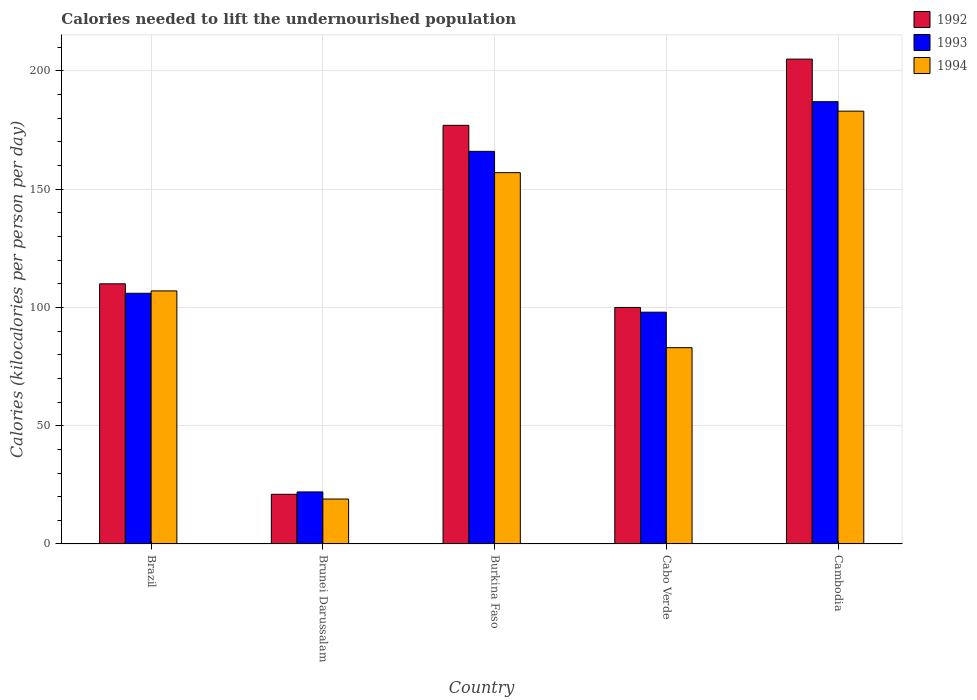How many groups of bars are there?
Ensure brevity in your answer.  5. How many bars are there on the 5th tick from the left?
Your response must be concise. 3. What is the label of the 2nd group of bars from the left?
Offer a very short reply. Brunei Darussalam. In how many cases, is the number of bars for a given country not equal to the number of legend labels?
Your answer should be very brief. 0. Across all countries, what is the maximum total calories needed to lift the undernourished population in 1993?
Offer a terse response. 187. In which country was the total calories needed to lift the undernourished population in 1992 maximum?
Offer a terse response. Cambodia. In which country was the total calories needed to lift the undernourished population in 1992 minimum?
Give a very brief answer. Brunei Darussalam. What is the total total calories needed to lift the undernourished population in 1992 in the graph?
Make the answer very short. 613. What is the difference between the total calories needed to lift the undernourished population in 1994 in Cabo Verde and that in Cambodia?
Provide a succinct answer. -100. What is the difference between the total calories needed to lift the undernourished population in 1993 in Brunei Darussalam and the total calories needed to lift the undernourished population in 1994 in Brazil?
Offer a very short reply. -85. What is the average total calories needed to lift the undernourished population in 1992 per country?
Ensure brevity in your answer.  122.6. What is the difference between the total calories needed to lift the undernourished population of/in 1993 and total calories needed to lift the undernourished population of/in 1992 in Burkina Faso?
Provide a succinct answer. -11. In how many countries, is the total calories needed to lift the undernourished population in 1992 greater than 200 kilocalories?
Offer a very short reply. 1. What is the ratio of the total calories needed to lift the undernourished population in 1994 in Burkina Faso to that in Cabo Verde?
Your answer should be very brief. 1.89. Is the total calories needed to lift the undernourished population in 1993 in Brazil less than that in Cabo Verde?
Provide a succinct answer. No. Is the difference between the total calories needed to lift the undernourished population in 1993 in Burkina Faso and Cambodia greater than the difference between the total calories needed to lift the undernourished population in 1992 in Burkina Faso and Cambodia?
Your response must be concise. Yes. What is the difference between the highest and the second highest total calories needed to lift the undernourished population in 1993?
Your response must be concise. -81. What is the difference between the highest and the lowest total calories needed to lift the undernourished population in 1992?
Provide a short and direct response. 184. In how many countries, is the total calories needed to lift the undernourished population in 1994 greater than the average total calories needed to lift the undernourished population in 1994 taken over all countries?
Your answer should be compact. 2. Is the sum of the total calories needed to lift the undernourished population in 1993 in Brunei Darussalam and Cabo Verde greater than the maximum total calories needed to lift the undernourished population in 1992 across all countries?
Keep it short and to the point. No. What does the 1st bar from the left in Brunei Darussalam represents?
Make the answer very short. 1992. What does the 3rd bar from the right in Brazil represents?
Provide a succinct answer. 1992. How many countries are there in the graph?
Your answer should be compact. 5. Does the graph contain any zero values?
Give a very brief answer. No. Where does the legend appear in the graph?
Provide a succinct answer. Top right. How many legend labels are there?
Your response must be concise. 3. What is the title of the graph?
Provide a succinct answer. Calories needed to lift the undernourished population. Does "2012" appear as one of the legend labels in the graph?
Give a very brief answer. No. What is the label or title of the Y-axis?
Ensure brevity in your answer.  Calories (kilocalories per person per day). What is the Calories (kilocalories per person per day) of 1992 in Brazil?
Ensure brevity in your answer.  110. What is the Calories (kilocalories per person per day) in 1993 in Brazil?
Keep it short and to the point. 106. What is the Calories (kilocalories per person per day) in 1994 in Brazil?
Your answer should be compact. 107. What is the Calories (kilocalories per person per day) of 1992 in Burkina Faso?
Keep it short and to the point. 177. What is the Calories (kilocalories per person per day) in 1993 in Burkina Faso?
Your response must be concise. 166. What is the Calories (kilocalories per person per day) in 1994 in Burkina Faso?
Ensure brevity in your answer.  157. What is the Calories (kilocalories per person per day) in 1992 in Cabo Verde?
Your answer should be very brief. 100. What is the Calories (kilocalories per person per day) in 1994 in Cabo Verde?
Provide a short and direct response. 83. What is the Calories (kilocalories per person per day) in 1992 in Cambodia?
Offer a terse response. 205. What is the Calories (kilocalories per person per day) in 1993 in Cambodia?
Offer a very short reply. 187. What is the Calories (kilocalories per person per day) in 1994 in Cambodia?
Ensure brevity in your answer.  183. Across all countries, what is the maximum Calories (kilocalories per person per day) of 1992?
Provide a succinct answer. 205. Across all countries, what is the maximum Calories (kilocalories per person per day) in 1993?
Ensure brevity in your answer.  187. Across all countries, what is the maximum Calories (kilocalories per person per day) in 1994?
Provide a short and direct response. 183. Across all countries, what is the minimum Calories (kilocalories per person per day) in 1992?
Ensure brevity in your answer.  21. Across all countries, what is the minimum Calories (kilocalories per person per day) of 1994?
Offer a terse response. 19. What is the total Calories (kilocalories per person per day) of 1992 in the graph?
Provide a short and direct response. 613. What is the total Calories (kilocalories per person per day) of 1993 in the graph?
Make the answer very short. 579. What is the total Calories (kilocalories per person per day) in 1994 in the graph?
Provide a short and direct response. 549. What is the difference between the Calories (kilocalories per person per day) in 1992 in Brazil and that in Brunei Darussalam?
Provide a short and direct response. 89. What is the difference between the Calories (kilocalories per person per day) of 1992 in Brazil and that in Burkina Faso?
Make the answer very short. -67. What is the difference between the Calories (kilocalories per person per day) in 1993 in Brazil and that in Burkina Faso?
Provide a short and direct response. -60. What is the difference between the Calories (kilocalories per person per day) of 1994 in Brazil and that in Burkina Faso?
Offer a very short reply. -50. What is the difference between the Calories (kilocalories per person per day) of 1992 in Brazil and that in Cabo Verde?
Ensure brevity in your answer.  10. What is the difference between the Calories (kilocalories per person per day) of 1992 in Brazil and that in Cambodia?
Keep it short and to the point. -95. What is the difference between the Calories (kilocalories per person per day) of 1993 in Brazil and that in Cambodia?
Offer a very short reply. -81. What is the difference between the Calories (kilocalories per person per day) in 1994 in Brazil and that in Cambodia?
Give a very brief answer. -76. What is the difference between the Calories (kilocalories per person per day) in 1992 in Brunei Darussalam and that in Burkina Faso?
Provide a short and direct response. -156. What is the difference between the Calories (kilocalories per person per day) of 1993 in Brunei Darussalam and that in Burkina Faso?
Provide a short and direct response. -144. What is the difference between the Calories (kilocalories per person per day) in 1994 in Brunei Darussalam and that in Burkina Faso?
Your answer should be very brief. -138. What is the difference between the Calories (kilocalories per person per day) of 1992 in Brunei Darussalam and that in Cabo Verde?
Ensure brevity in your answer.  -79. What is the difference between the Calories (kilocalories per person per day) in 1993 in Brunei Darussalam and that in Cabo Verde?
Your answer should be compact. -76. What is the difference between the Calories (kilocalories per person per day) of 1994 in Brunei Darussalam and that in Cabo Verde?
Keep it short and to the point. -64. What is the difference between the Calories (kilocalories per person per day) of 1992 in Brunei Darussalam and that in Cambodia?
Offer a very short reply. -184. What is the difference between the Calories (kilocalories per person per day) in 1993 in Brunei Darussalam and that in Cambodia?
Offer a very short reply. -165. What is the difference between the Calories (kilocalories per person per day) of 1994 in Brunei Darussalam and that in Cambodia?
Ensure brevity in your answer.  -164. What is the difference between the Calories (kilocalories per person per day) of 1993 in Burkina Faso and that in Cabo Verde?
Provide a short and direct response. 68. What is the difference between the Calories (kilocalories per person per day) of 1992 in Burkina Faso and that in Cambodia?
Provide a short and direct response. -28. What is the difference between the Calories (kilocalories per person per day) of 1994 in Burkina Faso and that in Cambodia?
Keep it short and to the point. -26. What is the difference between the Calories (kilocalories per person per day) in 1992 in Cabo Verde and that in Cambodia?
Your answer should be very brief. -105. What is the difference between the Calories (kilocalories per person per day) in 1993 in Cabo Verde and that in Cambodia?
Your answer should be compact. -89. What is the difference between the Calories (kilocalories per person per day) of 1994 in Cabo Verde and that in Cambodia?
Keep it short and to the point. -100. What is the difference between the Calories (kilocalories per person per day) of 1992 in Brazil and the Calories (kilocalories per person per day) of 1993 in Brunei Darussalam?
Keep it short and to the point. 88. What is the difference between the Calories (kilocalories per person per day) of 1992 in Brazil and the Calories (kilocalories per person per day) of 1994 in Brunei Darussalam?
Offer a very short reply. 91. What is the difference between the Calories (kilocalories per person per day) in 1993 in Brazil and the Calories (kilocalories per person per day) in 1994 in Brunei Darussalam?
Make the answer very short. 87. What is the difference between the Calories (kilocalories per person per day) in 1992 in Brazil and the Calories (kilocalories per person per day) in 1993 in Burkina Faso?
Your answer should be very brief. -56. What is the difference between the Calories (kilocalories per person per day) of 1992 in Brazil and the Calories (kilocalories per person per day) of 1994 in Burkina Faso?
Offer a very short reply. -47. What is the difference between the Calories (kilocalories per person per day) of 1993 in Brazil and the Calories (kilocalories per person per day) of 1994 in Burkina Faso?
Your answer should be very brief. -51. What is the difference between the Calories (kilocalories per person per day) of 1992 in Brazil and the Calories (kilocalories per person per day) of 1994 in Cabo Verde?
Your answer should be very brief. 27. What is the difference between the Calories (kilocalories per person per day) of 1993 in Brazil and the Calories (kilocalories per person per day) of 1994 in Cabo Verde?
Ensure brevity in your answer.  23. What is the difference between the Calories (kilocalories per person per day) in 1992 in Brazil and the Calories (kilocalories per person per day) in 1993 in Cambodia?
Give a very brief answer. -77. What is the difference between the Calories (kilocalories per person per day) of 1992 in Brazil and the Calories (kilocalories per person per day) of 1994 in Cambodia?
Your answer should be compact. -73. What is the difference between the Calories (kilocalories per person per day) in 1993 in Brazil and the Calories (kilocalories per person per day) in 1994 in Cambodia?
Keep it short and to the point. -77. What is the difference between the Calories (kilocalories per person per day) in 1992 in Brunei Darussalam and the Calories (kilocalories per person per day) in 1993 in Burkina Faso?
Give a very brief answer. -145. What is the difference between the Calories (kilocalories per person per day) of 1992 in Brunei Darussalam and the Calories (kilocalories per person per day) of 1994 in Burkina Faso?
Keep it short and to the point. -136. What is the difference between the Calories (kilocalories per person per day) of 1993 in Brunei Darussalam and the Calories (kilocalories per person per day) of 1994 in Burkina Faso?
Give a very brief answer. -135. What is the difference between the Calories (kilocalories per person per day) in 1992 in Brunei Darussalam and the Calories (kilocalories per person per day) in 1993 in Cabo Verde?
Your answer should be compact. -77. What is the difference between the Calories (kilocalories per person per day) of 1992 in Brunei Darussalam and the Calories (kilocalories per person per day) of 1994 in Cabo Verde?
Offer a terse response. -62. What is the difference between the Calories (kilocalories per person per day) in 1993 in Brunei Darussalam and the Calories (kilocalories per person per day) in 1994 in Cabo Verde?
Offer a terse response. -61. What is the difference between the Calories (kilocalories per person per day) in 1992 in Brunei Darussalam and the Calories (kilocalories per person per day) in 1993 in Cambodia?
Offer a very short reply. -166. What is the difference between the Calories (kilocalories per person per day) of 1992 in Brunei Darussalam and the Calories (kilocalories per person per day) of 1994 in Cambodia?
Provide a succinct answer. -162. What is the difference between the Calories (kilocalories per person per day) in 1993 in Brunei Darussalam and the Calories (kilocalories per person per day) in 1994 in Cambodia?
Your answer should be very brief. -161. What is the difference between the Calories (kilocalories per person per day) of 1992 in Burkina Faso and the Calories (kilocalories per person per day) of 1993 in Cabo Verde?
Keep it short and to the point. 79. What is the difference between the Calories (kilocalories per person per day) in 1992 in Burkina Faso and the Calories (kilocalories per person per day) in 1994 in Cabo Verde?
Provide a succinct answer. 94. What is the difference between the Calories (kilocalories per person per day) of 1992 in Burkina Faso and the Calories (kilocalories per person per day) of 1993 in Cambodia?
Make the answer very short. -10. What is the difference between the Calories (kilocalories per person per day) of 1992 in Burkina Faso and the Calories (kilocalories per person per day) of 1994 in Cambodia?
Your response must be concise. -6. What is the difference between the Calories (kilocalories per person per day) in 1992 in Cabo Verde and the Calories (kilocalories per person per day) in 1993 in Cambodia?
Ensure brevity in your answer.  -87. What is the difference between the Calories (kilocalories per person per day) in 1992 in Cabo Verde and the Calories (kilocalories per person per day) in 1994 in Cambodia?
Offer a very short reply. -83. What is the difference between the Calories (kilocalories per person per day) of 1993 in Cabo Verde and the Calories (kilocalories per person per day) of 1994 in Cambodia?
Give a very brief answer. -85. What is the average Calories (kilocalories per person per day) of 1992 per country?
Provide a succinct answer. 122.6. What is the average Calories (kilocalories per person per day) of 1993 per country?
Make the answer very short. 115.8. What is the average Calories (kilocalories per person per day) of 1994 per country?
Provide a short and direct response. 109.8. What is the difference between the Calories (kilocalories per person per day) in 1992 and Calories (kilocalories per person per day) in 1993 in Brazil?
Keep it short and to the point. 4. What is the difference between the Calories (kilocalories per person per day) of 1992 and Calories (kilocalories per person per day) of 1994 in Brazil?
Give a very brief answer. 3. What is the difference between the Calories (kilocalories per person per day) in 1992 and Calories (kilocalories per person per day) in 1993 in Brunei Darussalam?
Provide a succinct answer. -1. What is the difference between the Calories (kilocalories per person per day) of 1993 and Calories (kilocalories per person per day) of 1994 in Brunei Darussalam?
Provide a succinct answer. 3. What is the difference between the Calories (kilocalories per person per day) in 1993 and Calories (kilocalories per person per day) in 1994 in Burkina Faso?
Provide a short and direct response. 9. What is the difference between the Calories (kilocalories per person per day) of 1992 and Calories (kilocalories per person per day) of 1993 in Cabo Verde?
Offer a very short reply. 2. What is the difference between the Calories (kilocalories per person per day) of 1992 and Calories (kilocalories per person per day) of 1994 in Cabo Verde?
Make the answer very short. 17. What is the difference between the Calories (kilocalories per person per day) in 1993 and Calories (kilocalories per person per day) in 1994 in Cabo Verde?
Provide a succinct answer. 15. What is the difference between the Calories (kilocalories per person per day) in 1992 and Calories (kilocalories per person per day) in 1993 in Cambodia?
Your answer should be compact. 18. What is the difference between the Calories (kilocalories per person per day) in 1993 and Calories (kilocalories per person per day) in 1994 in Cambodia?
Provide a short and direct response. 4. What is the ratio of the Calories (kilocalories per person per day) of 1992 in Brazil to that in Brunei Darussalam?
Give a very brief answer. 5.24. What is the ratio of the Calories (kilocalories per person per day) in 1993 in Brazil to that in Brunei Darussalam?
Make the answer very short. 4.82. What is the ratio of the Calories (kilocalories per person per day) in 1994 in Brazil to that in Brunei Darussalam?
Keep it short and to the point. 5.63. What is the ratio of the Calories (kilocalories per person per day) in 1992 in Brazil to that in Burkina Faso?
Your response must be concise. 0.62. What is the ratio of the Calories (kilocalories per person per day) in 1993 in Brazil to that in Burkina Faso?
Ensure brevity in your answer.  0.64. What is the ratio of the Calories (kilocalories per person per day) in 1994 in Brazil to that in Burkina Faso?
Provide a succinct answer. 0.68. What is the ratio of the Calories (kilocalories per person per day) in 1992 in Brazil to that in Cabo Verde?
Provide a succinct answer. 1.1. What is the ratio of the Calories (kilocalories per person per day) in 1993 in Brazil to that in Cabo Verde?
Offer a terse response. 1.08. What is the ratio of the Calories (kilocalories per person per day) of 1994 in Brazil to that in Cabo Verde?
Make the answer very short. 1.29. What is the ratio of the Calories (kilocalories per person per day) of 1992 in Brazil to that in Cambodia?
Give a very brief answer. 0.54. What is the ratio of the Calories (kilocalories per person per day) of 1993 in Brazil to that in Cambodia?
Your answer should be very brief. 0.57. What is the ratio of the Calories (kilocalories per person per day) of 1994 in Brazil to that in Cambodia?
Your answer should be very brief. 0.58. What is the ratio of the Calories (kilocalories per person per day) in 1992 in Brunei Darussalam to that in Burkina Faso?
Make the answer very short. 0.12. What is the ratio of the Calories (kilocalories per person per day) in 1993 in Brunei Darussalam to that in Burkina Faso?
Give a very brief answer. 0.13. What is the ratio of the Calories (kilocalories per person per day) of 1994 in Brunei Darussalam to that in Burkina Faso?
Your response must be concise. 0.12. What is the ratio of the Calories (kilocalories per person per day) of 1992 in Brunei Darussalam to that in Cabo Verde?
Offer a terse response. 0.21. What is the ratio of the Calories (kilocalories per person per day) in 1993 in Brunei Darussalam to that in Cabo Verde?
Provide a succinct answer. 0.22. What is the ratio of the Calories (kilocalories per person per day) in 1994 in Brunei Darussalam to that in Cabo Verde?
Provide a succinct answer. 0.23. What is the ratio of the Calories (kilocalories per person per day) in 1992 in Brunei Darussalam to that in Cambodia?
Your response must be concise. 0.1. What is the ratio of the Calories (kilocalories per person per day) of 1993 in Brunei Darussalam to that in Cambodia?
Provide a short and direct response. 0.12. What is the ratio of the Calories (kilocalories per person per day) in 1994 in Brunei Darussalam to that in Cambodia?
Give a very brief answer. 0.1. What is the ratio of the Calories (kilocalories per person per day) of 1992 in Burkina Faso to that in Cabo Verde?
Keep it short and to the point. 1.77. What is the ratio of the Calories (kilocalories per person per day) in 1993 in Burkina Faso to that in Cabo Verde?
Give a very brief answer. 1.69. What is the ratio of the Calories (kilocalories per person per day) in 1994 in Burkina Faso to that in Cabo Verde?
Ensure brevity in your answer.  1.89. What is the ratio of the Calories (kilocalories per person per day) in 1992 in Burkina Faso to that in Cambodia?
Offer a terse response. 0.86. What is the ratio of the Calories (kilocalories per person per day) in 1993 in Burkina Faso to that in Cambodia?
Keep it short and to the point. 0.89. What is the ratio of the Calories (kilocalories per person per day) of 1994 in Burkina Faso to that in Cambodia?
Keep it short and to the point. 0.86. What is the ratio of the Calories (kilocalories per person per day) of 1992 in Cabo Verde to that in Cambodia?
Provide a short and direct response. 0.49. What is the ratio of the Calories (kilocalories per person per day) in 1993 in Cabo Verde to that in Cambodia?
Make the answer very short. 0.52. What is the ratio of the Calories (kilocalories per person per day) of 1994 in Cabo Verde to that in Cambodia?
Ensure brevity in your answer.  0.45. What is the difference between the highest and the lowest Calories (kilocalories per person per day) in 1992?
Your answer should be very brief. 184. What is the difference between the highest and the lowest Calories (kilocalories per person per day) in 1993?
Provide a succinct answer. 165. What is the difference between the highest and the lowest Calories (kilocalories per person per day) of 1994?
Your answer should be compact. 164. 